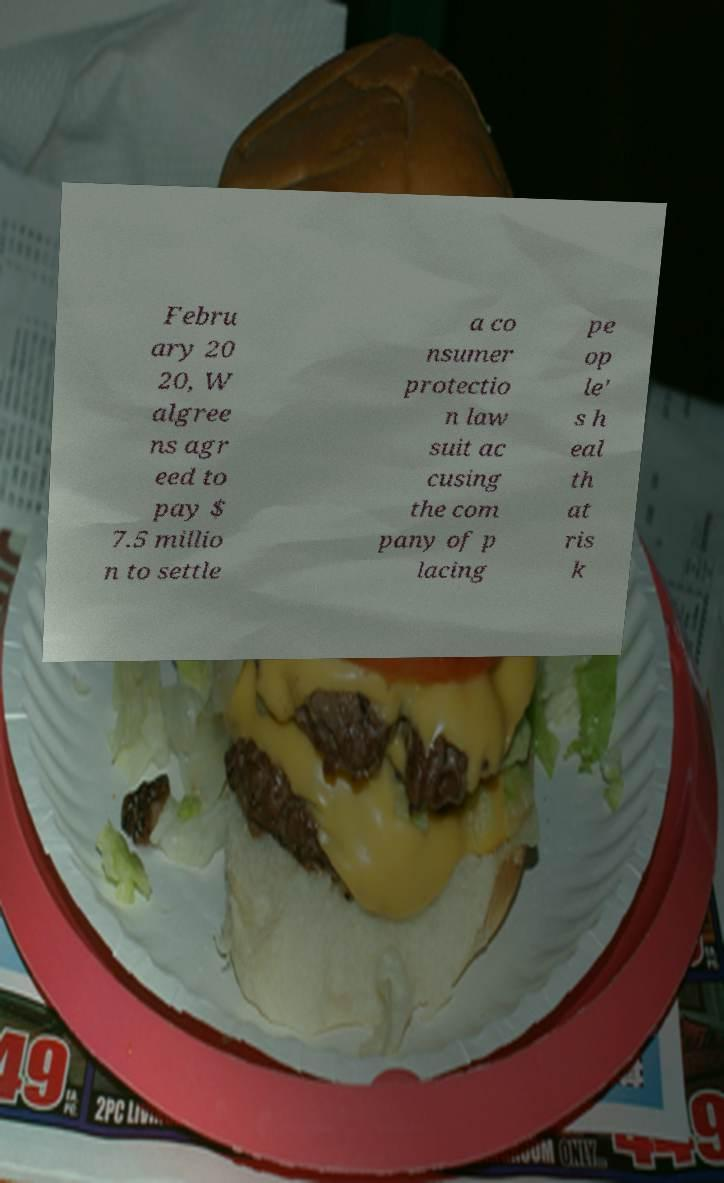Could you extract and type out the text from this image? Febru ary 20 20, W algree ns agr eed to pay $ 7.5 millio n to settle a co nsumer protectio n law suit ac cusing the com pany of p lacing pe op le' s h eal th at ris k 